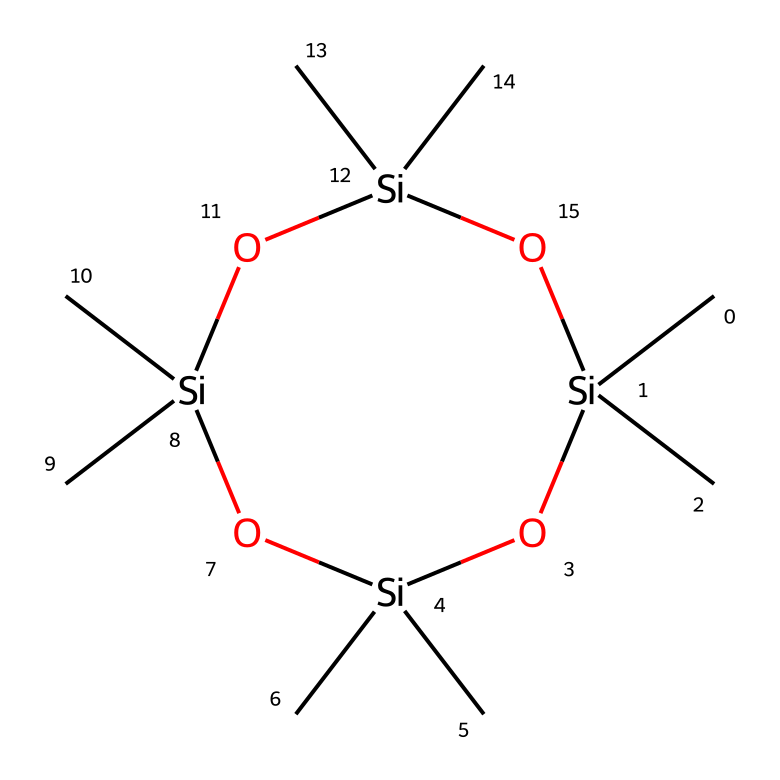How many silicon atoms are present in this chemical? By analyzing the SMILES representation, we can see that there are four silicon (Si) atoms indicated in the cyclic structure. Each silicon is part of the framework of the molecule.
Answer: four What is the total number of carbon atoms in this molecule? The SMILES structure indicates that each silicon is surrounded by two carbon groups (C), and since there are four silicon atoms, the total number of carbon atoms is 8.
Answer: eight What type of bonding is primarily present in this silane structure? The predominant bonding in this molecule is covalent bonding, as the carbon and silicon atoms bond through shared electron pairs within the structure.
Answer: covalent How does octamethylcyclotetrasiloxane function in silicone-based lubricants? Octamethylcyclotetrasiloxane acts as a lubricant by reducing friction and wear between moving parts, thanks to its low viscosity and stable properties in various temperatures.
Answer: lubricant What is the significance of the cyclic nature of this compound? The cyclic structure allows for a unique arrangement of atoms that contributes to its flexibility and lower viscosity, enhancing its performance as a lubricant in various applications.
Answer: flexibility How many oxygen atoms are in this chemical? The SMILES notation includes four oxygen (O) atoms, each serving as a linkage that contributes to the siloxane bonding framework that defines this class of chemicals.
Answer: four 